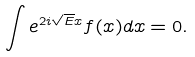<formula> <loc_0><loc_0><loc_500><loc_500>\int e ^ { 2 i \sqrt { E } x } f ( x ) d x = 0 .</formula> 